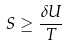Convert formula to latex. <formula><loc_0><loc_0><loc_500><loc_500>S \geq \frac { \delta U } { T }</formula> 